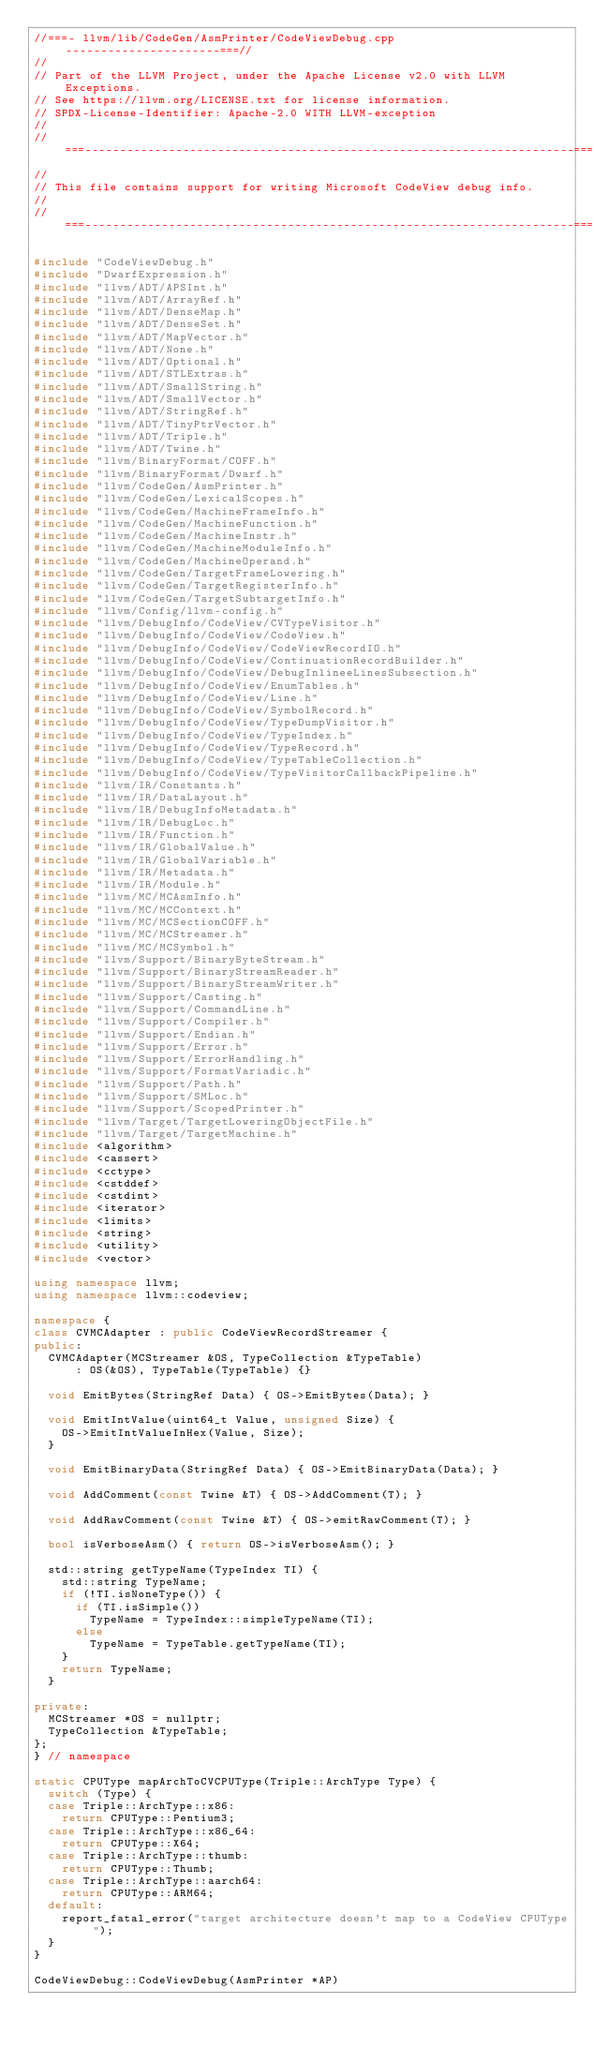<code> <loc_0><loc_0><loc_500><loc_500><_C++_>//===- llvm/lib/CodeGen/AsmPrinter/CodeViewDebug.cpp ----------------------===//
//
// Part of the LLVM Project, under the Apache License v2.0 with LLVM Exceptions.
// See https://llvm.org/LICENSE.txt for license information.
// SPDX-License-Identifier: Apache-2.0 WITH LLVM-exception
//
//===----------------------------------------------------------------------===//
//
// This file contains support for writing Microsoft CodeView debug info.
//
//===----------------------------------------------------------------------===//

#include "CodeViewDebug.h"
#include "DwarfExpression.h"
#include "llvm/ADT/APSInt.h"
#include "llvm/ADT/ArrayRef.h"
#include "llvm/ADT/DenseMap.h"
#include "llvm/ADT/DenseSet.h"
#include "llvm/ADT/MapVector.h"
#include "llvm/ADT/None.h"
#include "llvm/ADT/Optional.h"
#include "llvm/ADT/STLExtras.h"
#include "llvm/ADT/SmallString.h"
#include "llvm/ADT/SmallVector.h"
#include "llvm/ADT/StringRef.h"
#include "llvm/ADT/TinyPtrVector.h"
#include "llvm/ADT/Triple.h"
#include "llvm/ADT/Twine.h"
#include "llvm/BinaryFormat/COFF.h"
#include "llvm/BinaryFormat/Dwarf.h"
#include "llvm/CodeGen/AsmPrinter.h"
#include "llvm/CodeGen/LexicalScopes.h"
#include "llvm/CodeGen/MachineFrameInfo.h"
#include "llvm/CodeGen/MachineFunction.h"
#include "llvm/CodeGen/MachineInstr.h"
#include "llvm/CodeGen/MachineModuleInfo.h"
#include "llvm/CodeGen/MachineOperand.h"
#include "llvm/CodeGen/TargetFrameLowering.h"
#include "llvm/CodeGen/TargetRegisterInfo.h"
#include "llvm/CodeGen/TargetSubtargetInfo.h"
#include "llvm/Config/llvm-config.h"
#include "llvm/DebugInfo/CodeView/CVTypeVisitor.h"
#include "llvm/DebugInfo/CodeView/CodeView.h"
#include "llvm/DebugInfo/CodeView/CodeViewRecordIO.h"
#include "llvm/DebugInfo/CodeView/ContinuationRecordBuilder.h"
#include "llvm/DebugInfo/CodeView/DebugInlineeLinesSubsection.h"
#include "llvm/DebugInfo/CodeView/EnumTables.h"
#include "llvm/DebugInfo/CodeView/Line.h"
#include "llvm/DebugInfo/CodeView/SymbolRecord.h"
#include "llvm/DebugInfo/CodeView/TypeDumpVisitor.h"
#include "llvm/DebugInfo/CodeView/TypeIndex.h"
#include "llvm/DebugInfo/CodeView/TypeRecord.h"
#include "llvm/DebugInfo/CodeView/TypeTableCollection.h"
#include "llvm/DebugInfo/CodeView/TypeVisitorCallbackPipeline.h"
#include "llvm/IR/Constants.h"
#include "llvm/IR/DataLayout.h"
#include "llvm/IR/DebugInfoMetadata.h"
#include "llvm/IR/DebugLoc.h"
#include "llvm/IR/Function.h"
#include "llvm/IR/GlobalValue.h"
#include "llvm/IR/GlobalVariable.h"
#include "llvm/IR/Metadata.h"
#include "llvm/IR/Module.h"
#include "llvm/MC/MCAsmInfo.h"
#include "llvm/MC/MCContext.h"
#include "llvm/MC/MCSectionCOFF.h"
#include "llvm/MC/MCStreamer.h"
#include "llvm/MC/MCSymbol.h"
#include "llvm/Support/BinaryByteStream.h"
#include "llvm/Support/BinaryStreamReader.h"
#include "llvm/Support/BinaryStreamWriter.h"
#include "llvm/Support/Casting.h"
#include "llvm/Support/CommandLine.h"
#include "llvm/Support/Compiler.h"
#include "llvm/Support/Endian.h"
#include "llvm/Support/Error.h"
#include "llvm/Support/ErrorHandling.h"
#include "llvm/Support/FormatVariadic.h"
#include "llvm/Support/Path.h"
#include "llvm/Support/SMLoc.h"
#include "llvm/Support/ScopedPrinter.h"
#include "llvm/Target/TargetLoweringObjectFile.h"
#include "llvm/Target/TargetMachine.h"
#include <algorithm>
#include <cassert>
#include <cctype>
#include <cstddef>
#include <cstdint>
#include <iterator>
#include <limits>
#include <string>
#include <utility>
#include <vector>

using namespace llvm;
using namespace llvm::codeview;

namespace {
class CVMCAdapter : public CodeViewRecordStreamer {
public:
  CVMCAdapter(MCStreamer &OS, TypeCollection &TypeTable)
      : OS(&OS), TypeTable(TypeTable) {}

  void EmitBytes(StringRef Data) { OS->EmitBytes(Data); }

  void EmitIntValue(uint64_t Value, unsigned Size) {
    OS->EmitIntValueInHex(Value, Size);
  }

  void EmitBinaryData(StringRef Data) { OS->EmitBinaryData(Data); }

  void AddComment(const Twine &T) { OS->AddComment(T); }

  void AddRawComment(const Twine &T) { OS->emitRawComment(T); }

  bool isVerboseAsm() { return OS->isVerboseAsm(); }

  std::string getTypeName(TypeIndex TI) {
    std::string TypeName;
    if (!TI.isNoneType()) {
      if (TI.isSimple())
        TypeName = TypeIndex::simpleTypeName(TI);
      else
        TypeName = TypeTable.getTypeName(TI);
    }
    return TypeName;
  }

private:
  MCStreamer *OS = nullptr;
  TypeCollection &TypeTable;
};
} // namespace

static CPUType mapArchToCVCPUType(Triple::ArchType Type) {
  switch (Type) {
  case Triple::ArchType::x86:
    return CPUType::Pentium3;
  case Triple::ArchType::x86_64:
    return CPUType::X64;
  case Triple::ArchType::thumb:
    return CPUType::Thumb;
  case Triple::ArchType::aarch64:
    return CPUType::ARM64;
  default:
    report_fatal_error("target architecture doesn't map to a CodeView CPUType");
  }
}

CodeViewDebug::CodeViewDebug(AsmPrinter *AP)</code> 